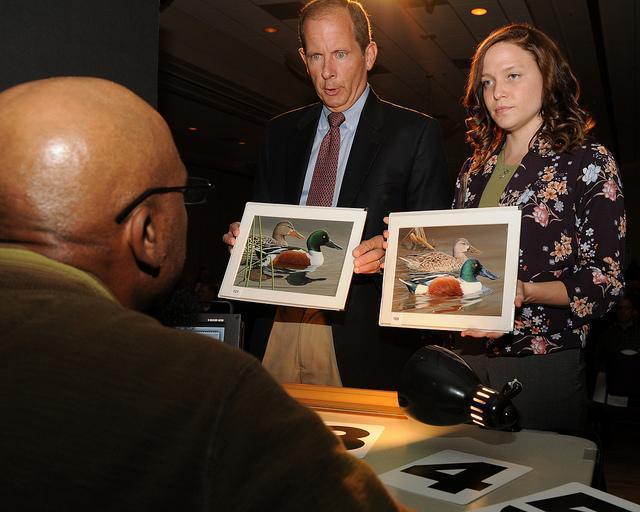How many people are in the photo?
Give a very brief answer. 3. 